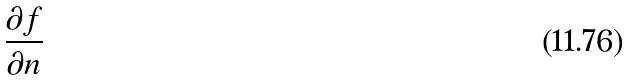<formula> <loc_0><loc_0><loc_500><loc_500>\frac { \partial f } { \partial n }</formula> 